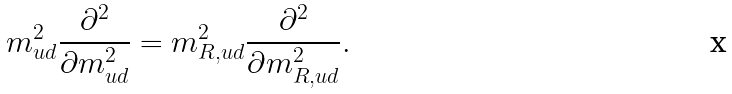<formula> <loc_0><loc_0><loc_500><loc_500>m _ { u d } ^ { 2 } \frac { \partial ^ { 2 } } { \partial m _ { u d } ^ { 2 } } = m _ { R , u d } ^ { 2 } \frac { \partial ^ { 2 } } { \partial m _ { R , u d } ^ { 2 } } .</formula> 